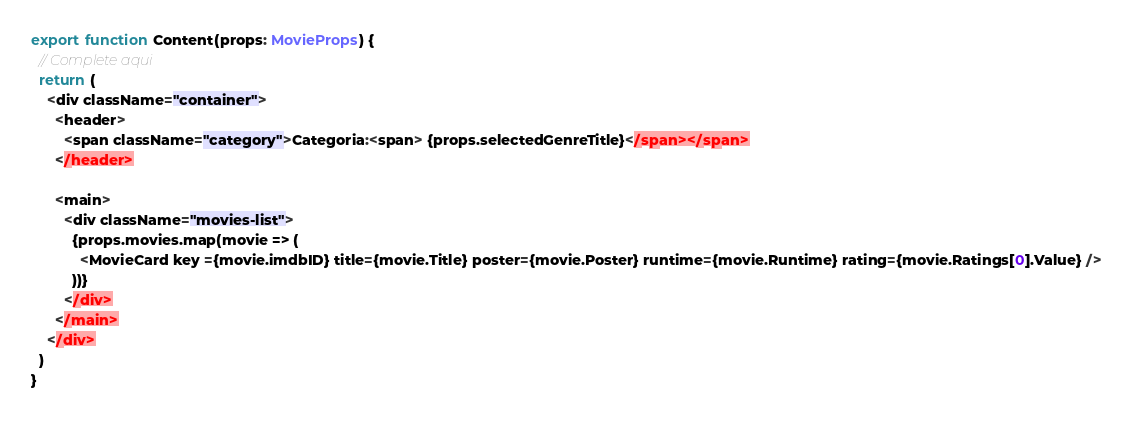<code> <loc_0><loc_0><loc_500><loc_500><_TypeScript_>

export function Content(props: MovieProps) {
  // Complete aqui
  return (
    <div className="container">
      <header>
        <span className="category">Categoria:<span> {props.selectedGenreTitle}</span></span>
      </header>

      <main>
        <div className="movies-list">
          {props.movies.map(movie => (
            <MovieCard key ={movie.imdbID} title={movie.Title} poster={movie.Poster} runtime={movie.Runtime} rating={movie.Ratings[0].Value} />
          ))}
        </div>
      </main>
    </div>
  )
}</code> 